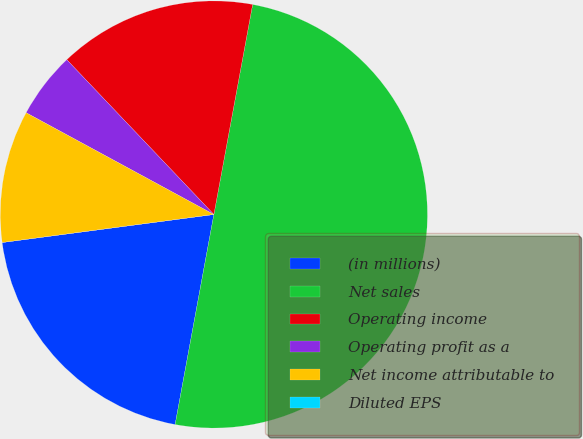Convert chart to OTSL. <chart><loc_0><loc_0><loc_500><loc_500><pie_chart><fcel>(in millions)<fcel>Net sales<fcel>Operating income<fcel>Operating profit as a<fcel>Net income attributable to<fcel>Diluted EPS<nl><fcel>20.0%<fcel>50.0%<fcel>15.0%<fcel>5.0%<fcel>10.0%<fcel>0.0%<nl></chart> 